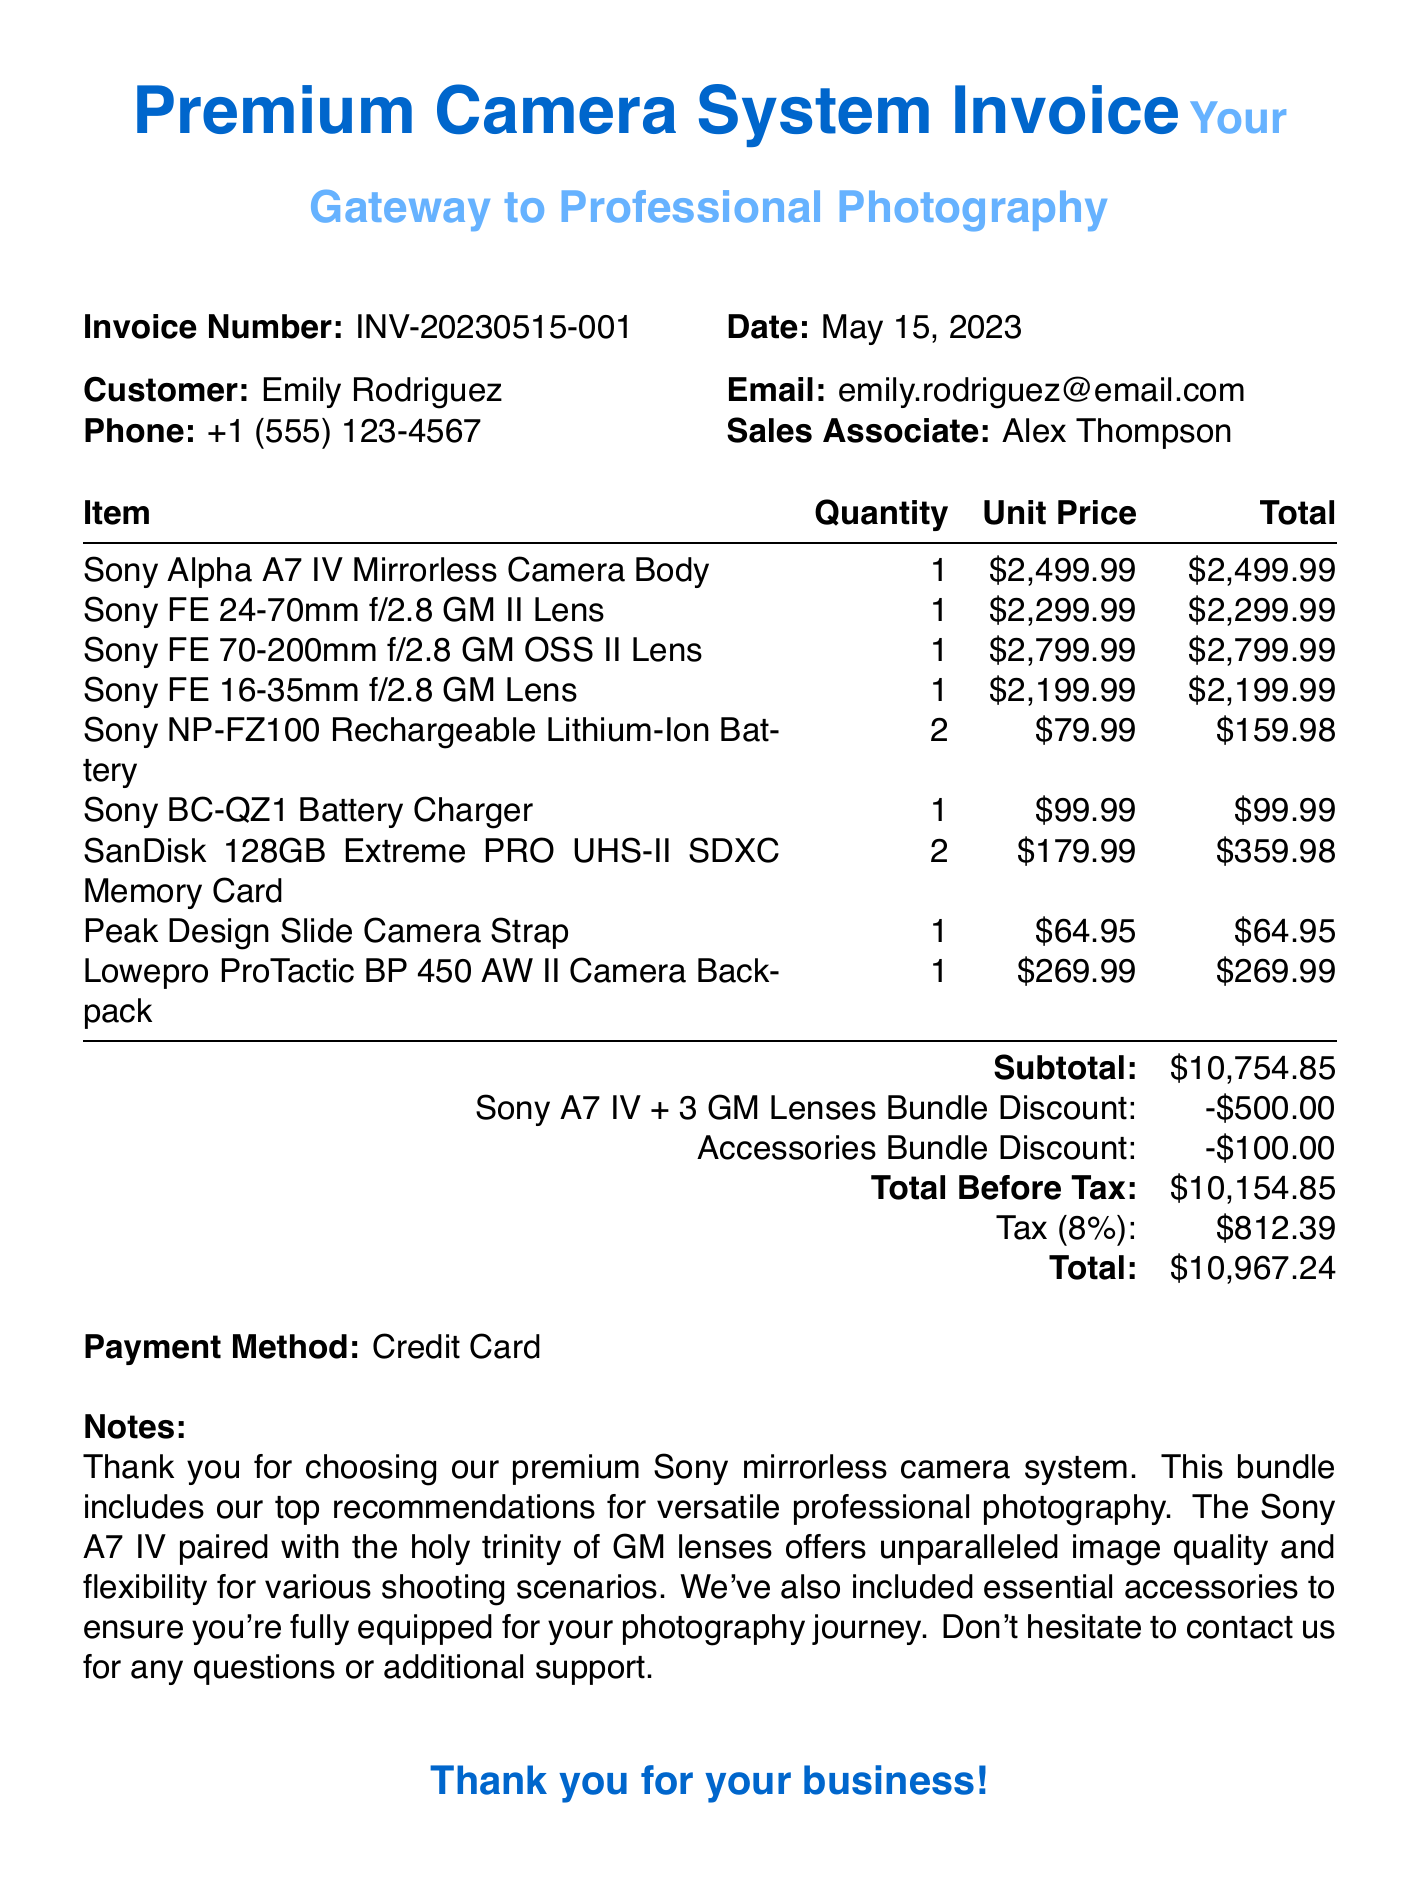What is the invoice number? The invoice number is clearly stated in the document as a unique identifier for this transaction.
Answer: INV-20230515-001 What is the total amount? The total amount is calculated at the end of the invoice, summing up all costs plus applicable tax.
Answer: $11,036.84 Who is the customer? The customer information includes the name, which is presented prominently in the document.
Answer: Emily Rodriguez What is the date of purchase? The date of purchase is mentioned at the top of the document, indicating when the transaction took place.
Answer: May 15, 2023 What type of camera is being sold? The document specifies the product category, which provides insight into the main item sold.
Answer: Sony Alpha A7 IV Mirrorless Camera Body How many lenses were purchased? The total number of lenses is calculated from the items listed under the lens category in the document.
Answer: 3 What discounts were applied? The invoice shows specific discounts that were applied to the overall sale, listed separately for clarity.
Answer: Sony A7 IV + 3 GM Lenses Bundle Discount & Accessories Bundle Discount What payment method was used? The payment method is indicated toward the end of the invoice, revealing how the customer settled the transaction.
Answer: Credit Card What is the subtotal before tax? The subtotal is an important figure that sums up the total costs before any taxes are applied, shown in the document.
Answer: $10,754.85 